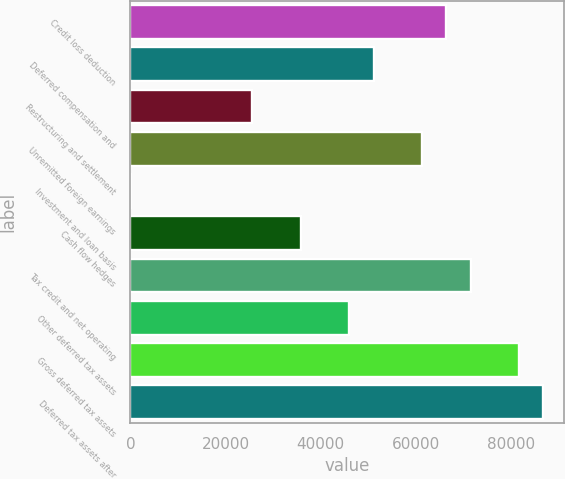Convert chart. <chart><loc_0><loc_0><loc_500><loc_500><bar_chart><fcel>Credit loss deduction<fcel>Deferred compensation and<fcel>Restructuring and settlement<fcel>Unremitted foreign earnings<fcel>Investment and loan basis<fcel>Cash flow hedges<fcel>Tax credit and net operating<fcel>Other deferred tax assets<fcel>Gross deferred tax assets<fcel>Deferred tax assets after<nl><fcel>66413.2<fcel>51100<fcel>25578<fcel>61308.8<fcel>56<fcel>35786.8<fcel>71517.6<fcel>45995.6<fcel>81726.4<fcel>86830.8<nl></chart> 